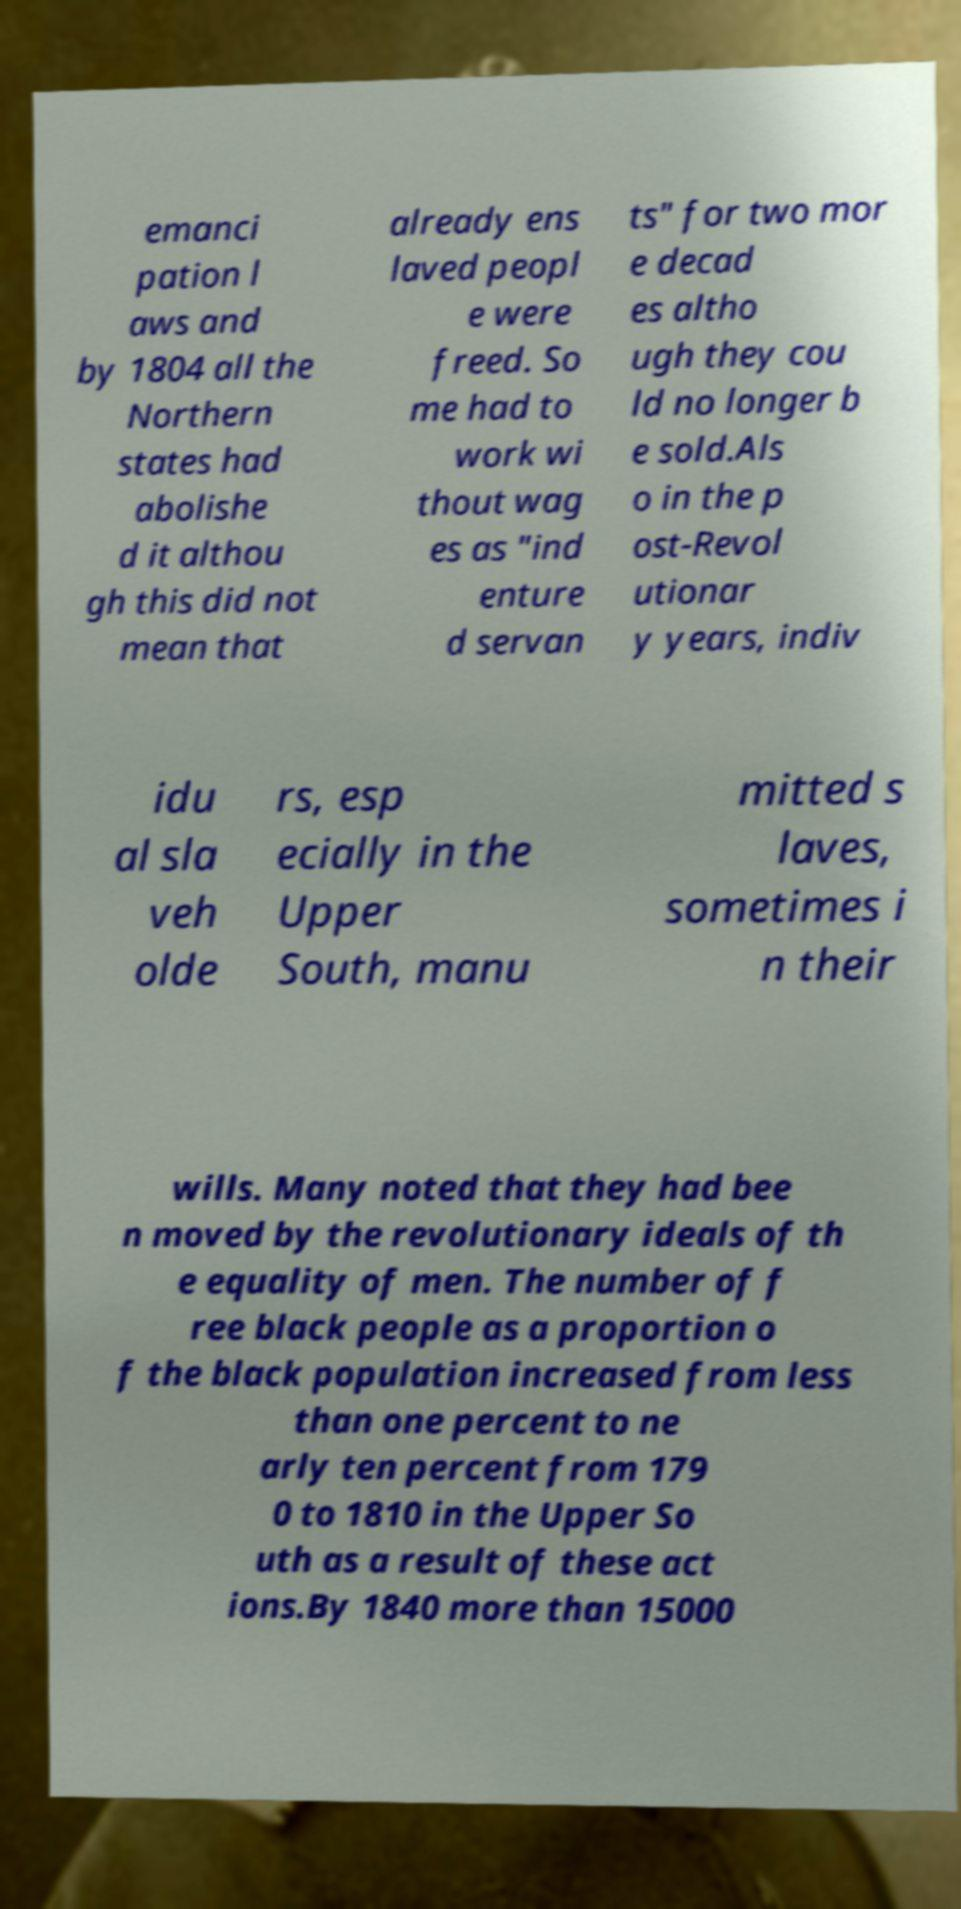Please identify and transcribe the text found in this image. emanci pation l aws and by 1804 all the Northern states had abolishe d it althou gh this did not mean that already ens laved peopl e were freed. So me had to work wi thout wag es as "ind enture d servan ts" for two mor e decad es altho ugh they cou ld no longer b e sold.Als o in the p ost-Revol utionar y years, indiv idu al sla veh olde rs, esp ecially in the Upper South, manu mitted s laves, sometimes i n their wills. Many noted that they had bee n moved by the revolutionary ideals of th e equality of men. The number of f ree black people as a proportion o f the black population increased from less than one percent to ne arly ten percent from 179 0 to 1810 in the Upper So uth as a result of these act ions.By 1840 more than 15000 